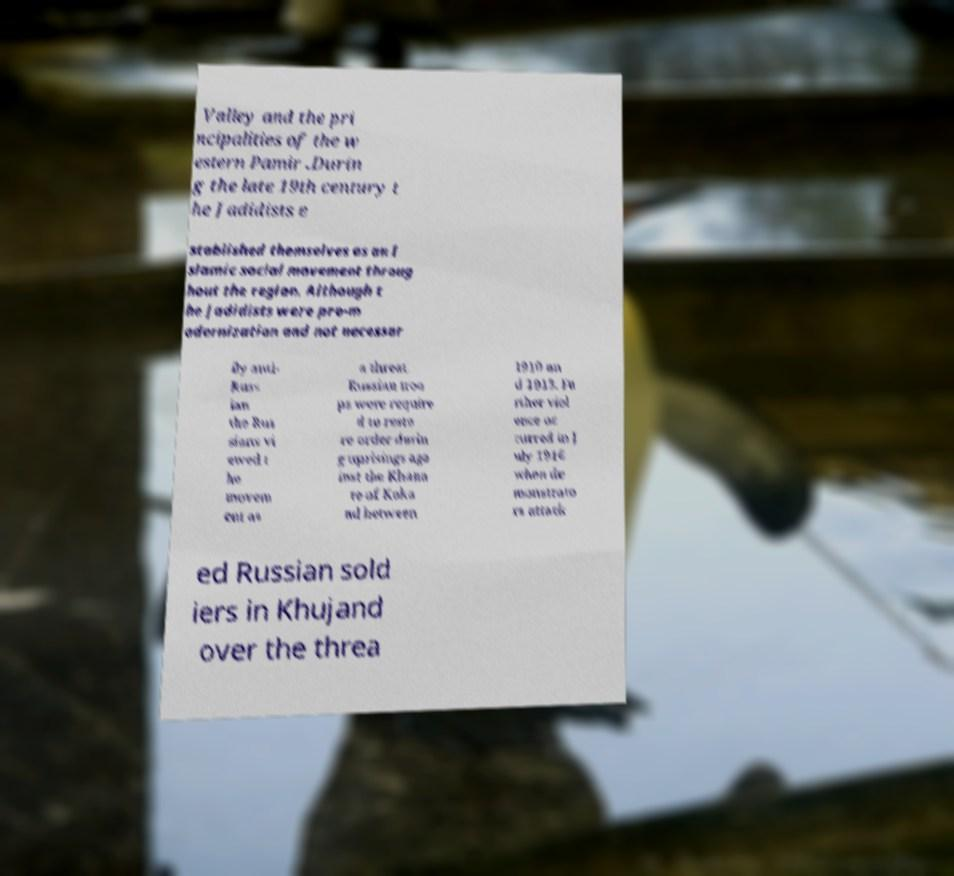Can you accurately transcribe the text from the provided image for me? Valley and the pri ncipalities of the w estern Pamir .Durin g the late 19th century t he Jadidists e stablished themselves as an I slamic social movement throug hout the region. Although t he Jadidists were pro-m odernization and not necessar ily anti- Russ ian the Rus sians vi ewed t he movem ent as a threat. Russian troo ps were require d to resto re order durin g uprisings aga inst the Khana te of Koka nd between 1910 an d 1913. Fu rther viol ence oc curred in J uly 1916 when de monstrato rs attack ed Russian sold iers in Khujand over the threa 